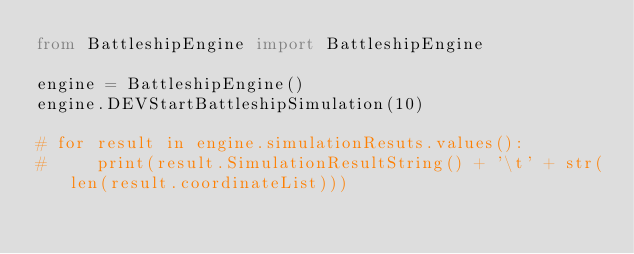Convert code to text. <code><loc_0><loc_0><loc_500><loc_500><_Python_>from BattleshipEngine import BattleshipEngine

engine = BattleshipEngine()
engine.DEVStartBattleshipSimulation(10)

# for result in engine.simulationResuts.values():
#     print(result.SimulationResultString() + '\t' + str(len(result.coordinateList)))

</code> 